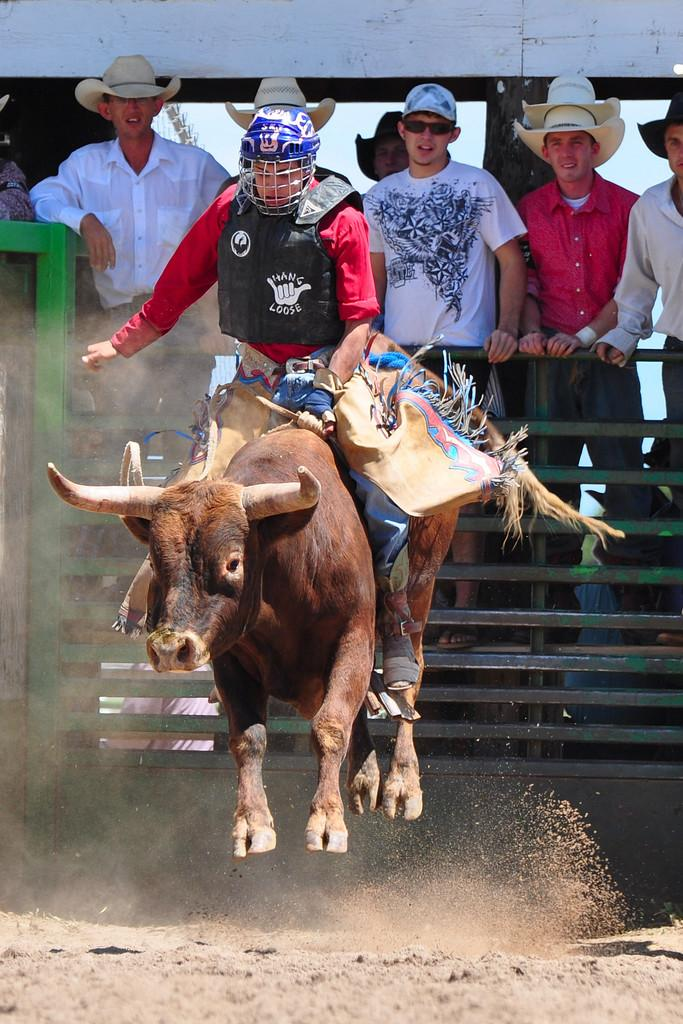What is the person in the image doing? There is a person sitting on an animal in the image. What can be seen in the background of the image? There are people wearing caps in the background of the image. What is the purpose of the fence visible in the image? The purpose of the fence is not specified in the facts, but it could be used for enclosing an area or providing a barrier. How many ghosts are present in the image? There are no ghosts present in the image; it only features a person sitting on an animal and people wearing caps in the background. 